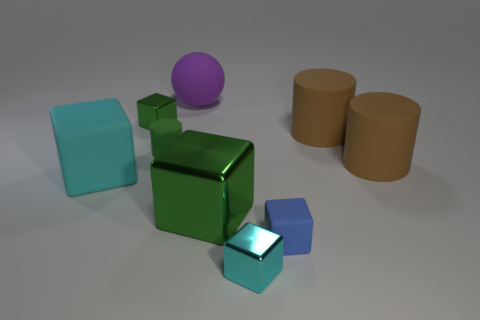Is there a yellow cylinder that has the same size as the green rubber cylinder?
Your answer should be very brief. No. There is a small metallic cube that is to the right of the matte sphere; does it have the same color as the big matte cube?
Your answer should be compact. Yes. What number of things are either tiny matte things or large matte cubes?
Provide a succinct answer. 3. Is the size of the block that is in front of the blue matte object the same as the tiny blue matte cube?
Offer a very short reply. Yes. There is a matte object that is in front of the sphere and behind the tiny green cylinder; how big is it?
Ensure brevity in your answer.  Large. What number of other objects are the same shape as the big purple object?
Your answer should be very brief. 0. What number of other things are made of the same material as the sphere?
Provide a short and direct response. 5. What size is the other cyan rubber thing that is the same shape as the tiny cyan object?
Give a very brief answer. Large. Do the large metal thing and the small matte cylinder have the same color?
Offer a terse response. Yes. What is the color of the big thing that is both on the left side of the large green metallic block and in front of the purple sphere?
Make the answer very short. Cyan. 